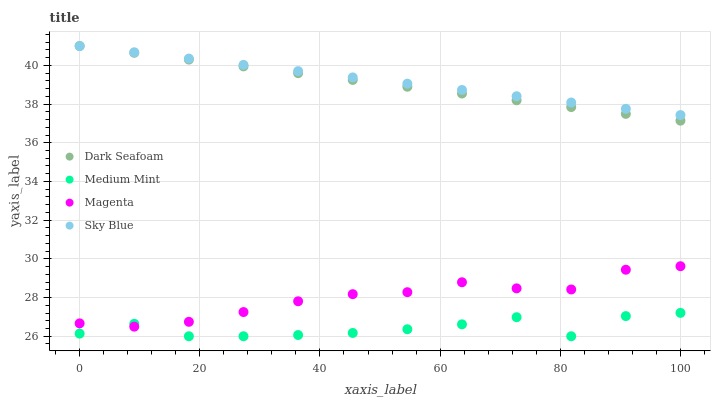Does Medium Mint have the minimum area under the curve?
Answer yes or no. Yes. Does Sky Blue have the maximum area under the curve?
Answer yes or no. Yes. Does Dark Seafoam have the minimum area under the curve?
Answer yes or no. No. Does Dark Seafoam have the maximum area under the curve?
Answer yes or no. No. Is Dark Seafoam the smoothest?
Answer yes or no. Yes. Is Medium Mint the roughest?
Answer yes or no. Yes. Is Sky Blue the smoothest?
Answer yes or no. No. Is Sky Blue the roughest?
Answer yes or no. No. Does Medium Mint have the lowest value?
Answer yes or no. Yes. Does Dark Seafoam have the lowest value?
Answer yes or no. No. Does Dark Seafoam have the highest value?
Answer yes or no. Yes. Does Magenta have the highest value?
Answer yes or no. No. Is Medium Mint less than Dark Seafoam?
Answer yes or no. Yes. Is Dark Seafoam greater than Medium Mint?
Answer yes or no. Yes. Does Medium Mint intersect Magenta?
Answer yes or no. Yes. Is Medium Mint less than Magenta?
Answer yes or no. No. Is Medium Mint greater than Magenta?
Answer yes or no. No. Does Medium Mint intersect Dark Seafoam?
Answer yes or no. No. 